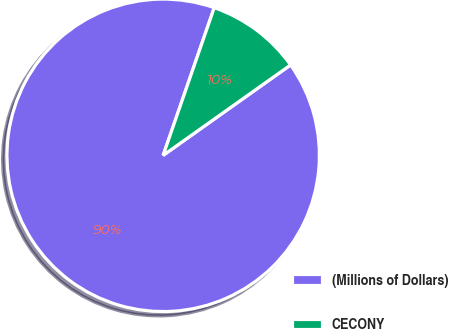Convert chart to OTSL. <chart><loc_0><loc_0><loc_500><loc_500><pie_chart><fcel>(Millions of Dollars)<fcel>CECONY<nl><fcel>90.12%<fcel>9.88%<nl></chart> 